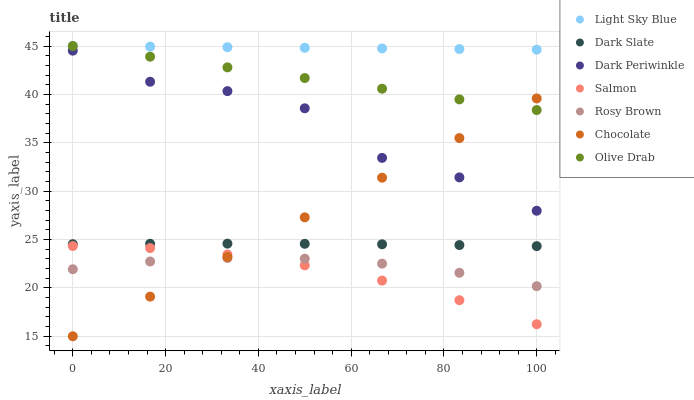Does Salmon have the minimum area under the curve?
Answer yes or no. Yes. Does Light Sky Blue have the maximum area under the curve?
Answer yes or no. Yes. Does Chocolate have the minimum area under the curve?
Answer yes or no. No. Does Chocolate have the maximum area under the curve?
Answer yes or no. No. Is Light Sky Blue the smoothest?
Answer yes or no. Yes. Is Dark Periwinkle the roughest?
Answer yes or no. Yes. Is Salmon the smoothest?
Answer yes or no. No. Is Salmon the roughest?
Answer yes or no. No. Does Chocolate have the lowest value?
Answer yes or no. Yes. Does Salmon have the lowest value?
Answer yes or no. No. Does Olive Drab have the highest value?
Answer yes or no. Yes. Does Salmon have the highest value?
Answer yes or no. No. Is Salmon less than Dark Periwinkle?
Answer yes or no. Yes. Is Dark Periwinkle greater than Salmon?
Answer yes or no. Yes. Does Olive Drab intersect Light Sky Blue?
Answer yes or no. Yes. Is Olive Drab less than Light Sky Blue?
Answer yes or no. No. Is Olive Drab greater than Light Sky Blue?
Answer yes or no. No. Does Salmon intersect Dark Periwinkle?
Answer yes or no. No. 